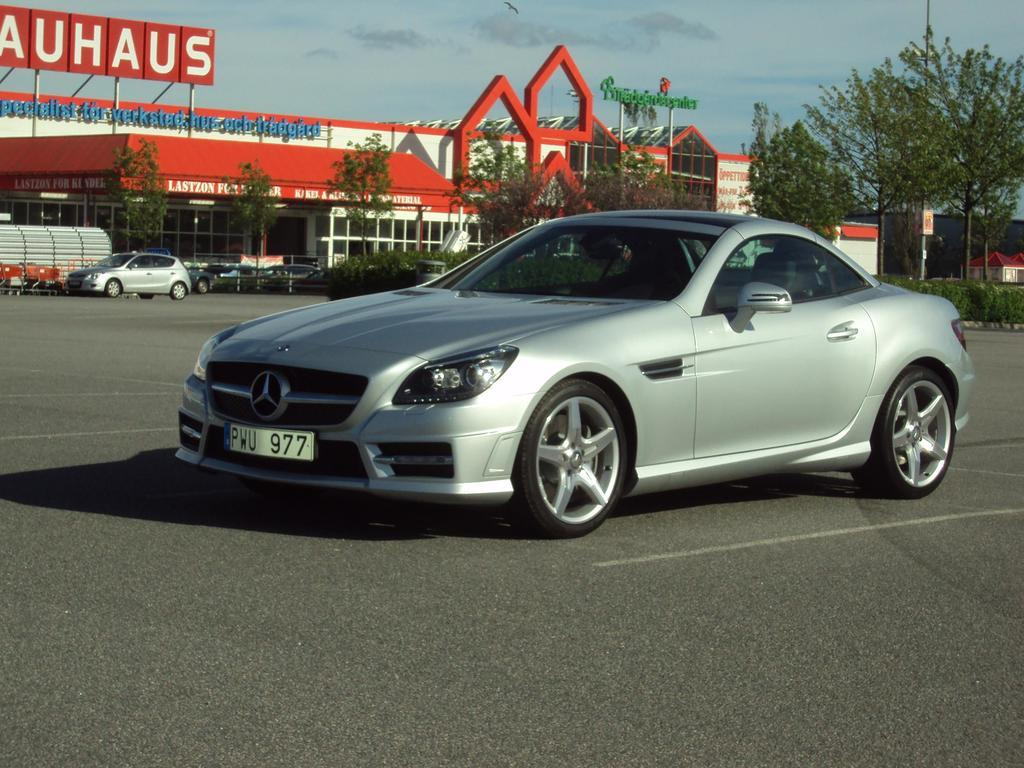<image>
Render a clear and concise summary of the photo. Silver car with a plate which says PWU977. 